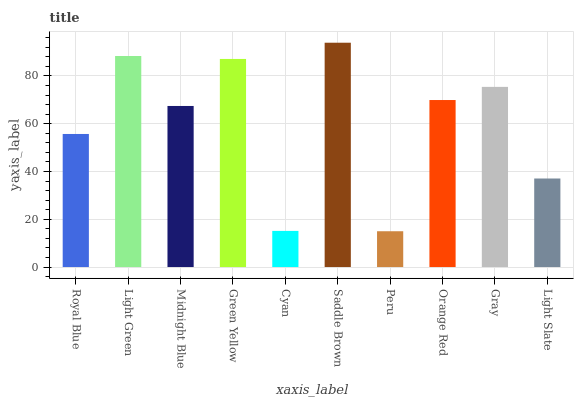Is Peru the minimum?
Answer yes or no. Yes. Is Saddle Brown the maximum?
Answer yes or no. Yes. Is Light Green the minimum?
Answer yes or no. No. Is Light Green the maximum?
Answer yes or no. No. Is Light Green greater than Royal Blue?
Answer yes or no. Yes. Is Royal Blue less than Light Green?
Answer yes or no. Yes. Is Royal Blue greater than Light Green?
Answer yes or no. No. Is Light Green less than Royal Blue?
Answer yes or no. No. Is Orange Red the high median?
Answer yes or no. Yes. Is Midnight Blue the low median?
Answer yes or no. Yes. Is Midnight Blue the high median?
Answer yes or no. No. Is Orange Red the low median?
Answer yes or no. No. 